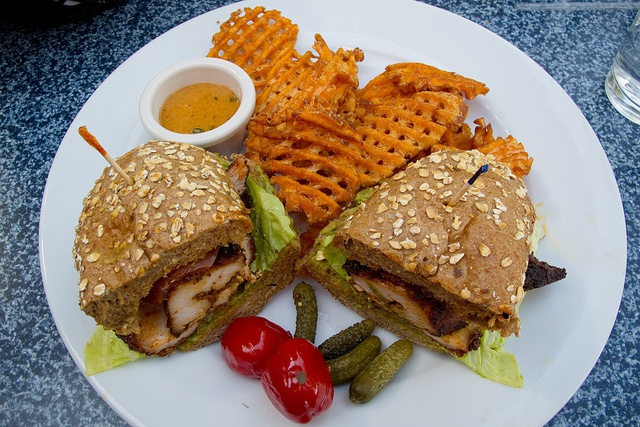Describe the objects in this image and their specific colors. I can see dining table in lightgray, brown, maroon, black, and tan tones, sandwich in black, tan, olive, and maroon tones, sandwich in black, tan, olive, and maroon tones, bowl in black, lightgray, tan, and orange tones, and cup in black, gray, lightgray, darkgray, and blue tones in this image. 